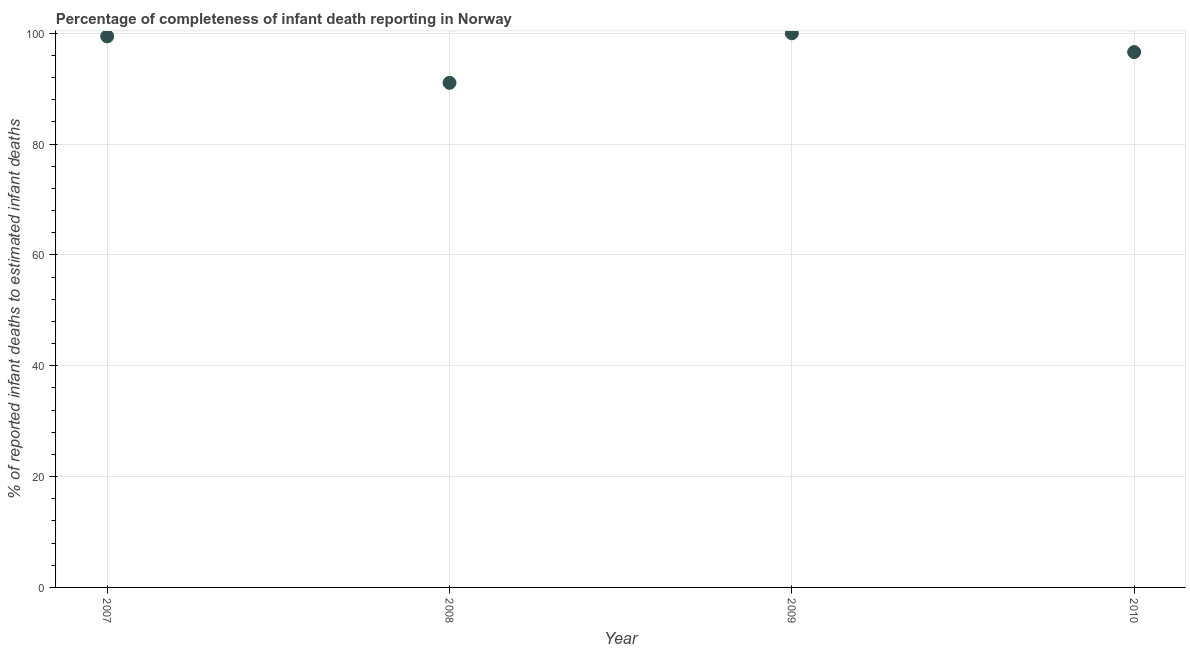What is the completeness of infant death reporting in 2008?
Provide a short and direct response. 91.06. Across all years, what is the maximum completeness of infant death reporting?
Provide a succinct answer. 100. Across all years, what is the minimum completeness of infant death reporting?
Your response must be concise. 91.06. In which year was the completeness of infant death reporting maximum?
Ensure brevity in your answer.  2009. What is the sum of the completeness of infant death reporting?
Your answer should be compact. 387.12. What is the difference between the completeness of infant death reporting in 2008 and 2010?
Your response must be concise. -5.55. What is the average completeness of infant death reporting per year?
Make the answer very short. 96.78. What is the median completeness of infant death reporting?
Provide a succinct answer. 98.03. What is the ratio of the completeness of infant death reporting in 2008 to that in 2010?
Ensure brevity in your answer.  0.94. What is the difference between the highest and the second highest completeness of infant death reporting?
Provide a short and direct response. 0.55. Is the sum of the completeness of infant death reporting in 2007 and 2009 greater than the maximum completeness of infant death reporting across all years?
Provide a succinct answer. Yes. What is the difference between the highest and the lowest completeness of infant death reporting?
Provide a succinct answer. 8.94. How many dotlines are there?
Keep it short and to the point. 1. Does the graph contain grids?
Your response must be concise. Yes. What is the title of the graph?
Your answer should be compact. Percentage of completeness of infant death reporting in Norway. What is the label or title of the X-axis?
Keep it short and to the point. Year. What is the label or title of the Y-axis?
Give a very brief answer. % of reported infant deaths to estimated infant deaths. What is the % of reported infant deaths to estimated infant deaths in 2007?
Provide a succinct answer. 99.45. What is the % of reported infant deaths to estimated infant deaths in 2008?
Provide a succinct answer. 91.06. What is the % of reported infant deaths to estimated infant deaths in 2009?
Give a very brief answer. 100. What is the % of reported infant deaths to estimated infant deaths in 2010?
Your response must be concise. 96.61. What is the difference between the % of reported infant deaths to estimated infant deaths in 2007 and 2008?
Provide a succinct answer. 8.39. What is the difference between the % of reported infant deaths to estimated infant deaths in 2007 and 2009?
Your answer should be very brief. -0.55. What is the difference between the % of reported infant deaths to estimated infant deaths in 2007 and 2010?
Provide a short and direct response. 2.84. What is the difference between the % of reported infant deaths to estimated infant deaths in 2008 and 2009?
Make the answer very short. -8.94. What is the difference between the % of reported infant deaths to estimated infant deaths in 2008 and 2010?
Your answer should be very brief. -5.55. What is the difference between the % of reported infant deaths to estimated infant deaths in 2009 and 2010?
Provide a succinct answer. 3.39. What is the ratio of the % of reported infant deaths to estimated infant deaths in 2007 to that in 2008?
Give a very brief answer. 1.09. What is the ratio of the % of reported infant deaths to estimated infant deaths in 2007 to that in 2010?
Give a very brief answer. 1.03. What is the ratio of the % of reported infant deaths to estimated infant deaths in 2008 to that in 2009?
Offer a very short reply. 0.91. What is the ratio of the % of reported infant deaths to estimated infant deaths in 2008 to that in 2010?
Make the answer very short. 0.94. What is the ratio of the % of reported infant deaths to estimated infant deaths in 2009 to that in 2010?
Your answer should be very brief. 1.03. 